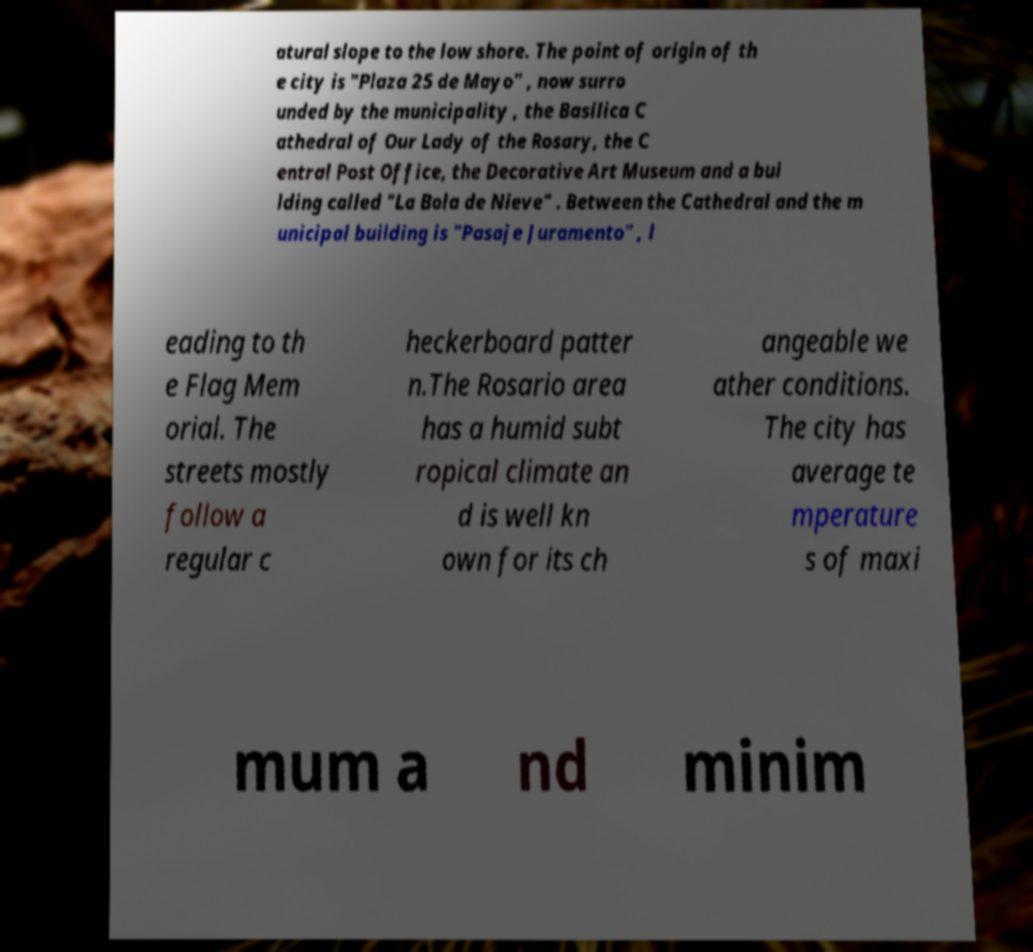Please identify and transcribe the text found in this image. atural slope to the low shore. The point of origin of th e city is "Plaza 25 de Mayo" , now surro unded by the municipality , the Basilica C athedral of Our Lady of the Rosary, the C entral Post Office, the Decorative Art Museum and a bui lding called "La Bola de Nieve" . Between the Cathedral and the m unicipal building is "Pasaje Juramento" , l eading to th e Flag Mem orial. The streets mostly follow a regular c heckerboard patter n.The Rosario area has a humid subt ropical climate an d is well kn own for its ch angeable we ather conditions. The city has average te mperature s of maxi mum a nd minim 